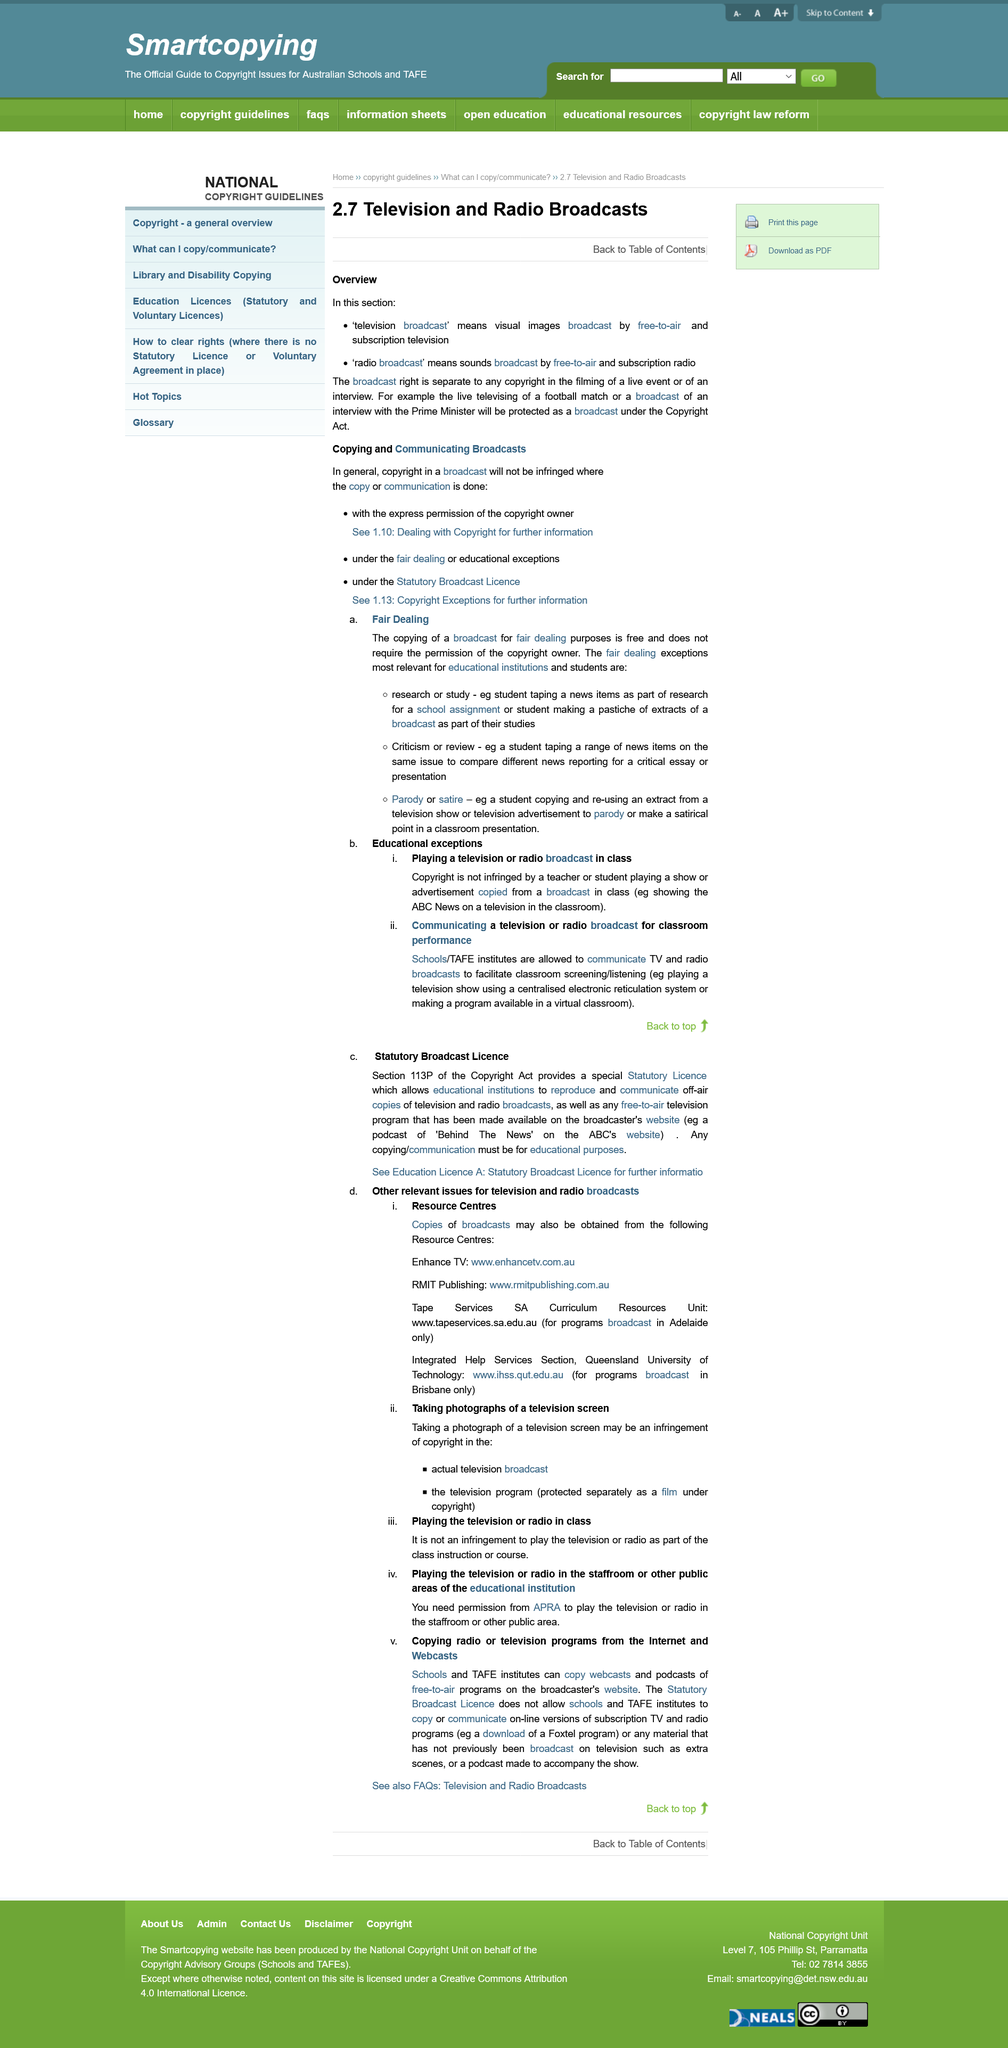Specify some key components in this picture. The playing of a television or radio broadcast in class is considered an educational exception to copyright infringement. Yes, it is possible to obtain copies of broadcasts from RMIT publishing. The topic of this page is television and radio broadcasts. Schools and TAFE institutes are not allowed to copy or communicate on-line versions of subscription TV and radio programs due to the existence of the Statutory Broadcast License. Permission from the Australian Performing Right Association (APRA) is required before playing the television or radio in the staffroom or any other public area. 